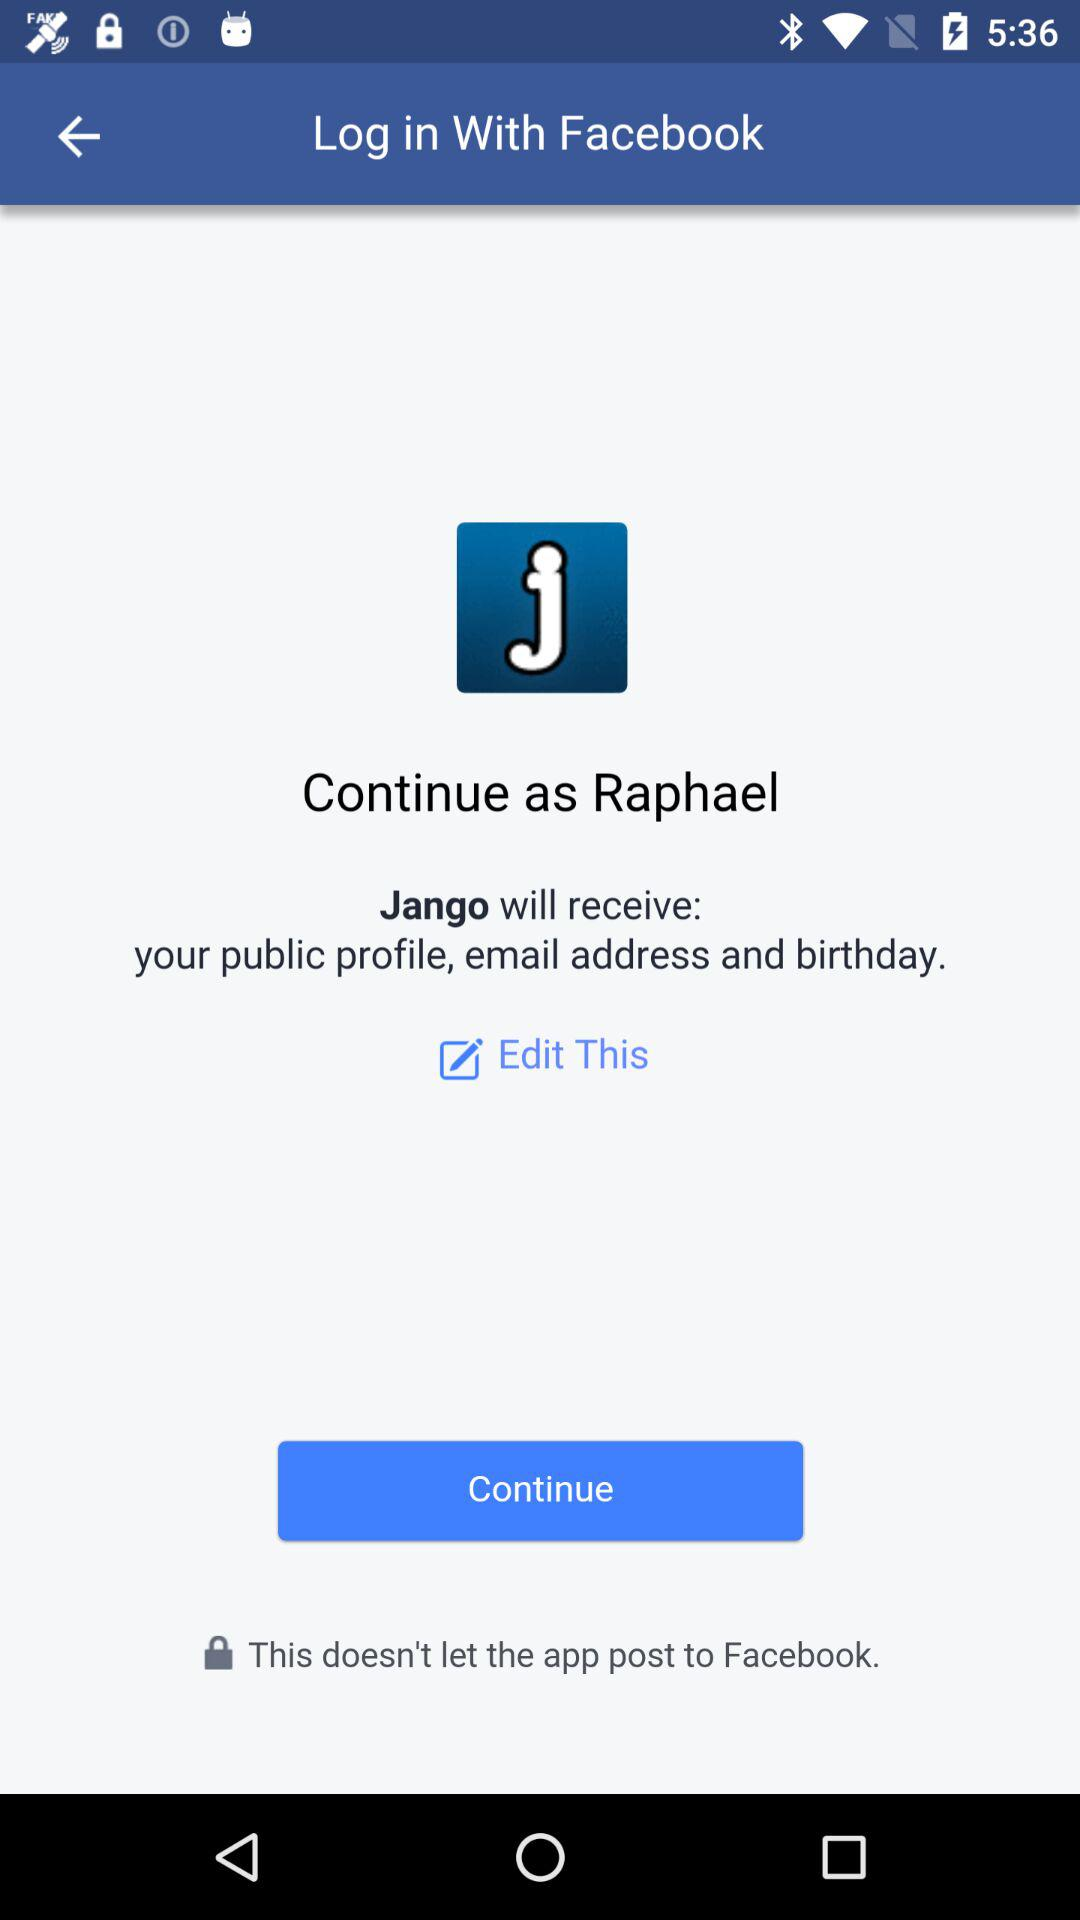What application is asking for permission? The application asking for permission is "Jango". 